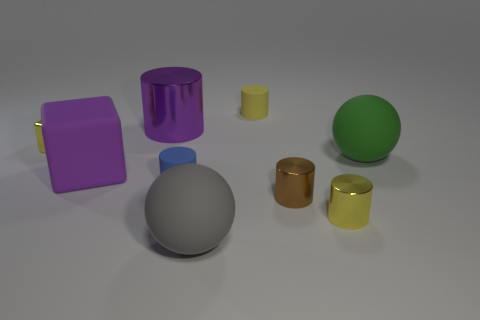Are there fewer big green matte things than brown blocks?
Ensure brevity in your answer.  No. There is a shiny object that is both on the left side of the large gray matte object and to the right of the rubber block; what color is it?
Offer a terse response. Purple. What is the material of the blue object that is the same shape as the small brown object?
Your response must be concise. Rubber. Is there any other thing that is the same size as the blue thing?
Ensure brevity in your answer.  Yes. Are there more metallic cylinders than cyan matte objects?
Offer a terse response. Yes. How big is the cylinder that is both behind the green thing and on the left side of the gray object?
Your answer should be very brief. Large. The small brown object has what shape?
Make the answer very short. Cylinder. What number of blue objects are the same shape as the large green rubber thing?
Your answer should be compact. 0. Are there fewer yellow shiny cylinders that are in front of the gray ball than purple cylinders that are behind the purple cylinder?
Provide a short and direct response. No. How many gray matte spheres are behind the rubber object in front of the tiny blue rubber cylinder?
Your answer should be compact. 0. 